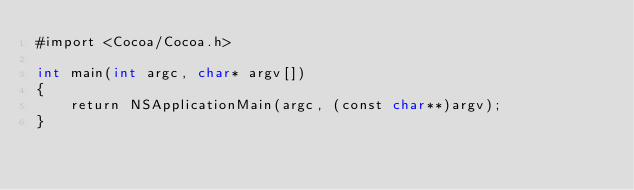<code> <loc_0><loc_0><loc_500><loc_500><_ObjectiveC_>#import <Cocoa/Cocoa.h>

int main(int argc, char* argv[])
{
	return NSApplicationMain(argc, (const char**)argv);
}
</code> 